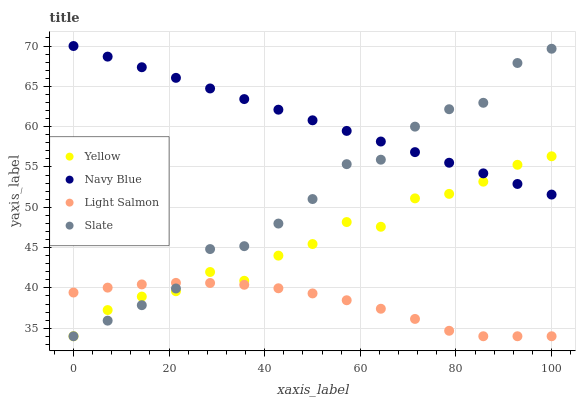Does Light Salmon have the minimum area under the curve?
Answer yes or no. Yes. Does Navy Blue have the maximum area under the curve?
Answer yes or no. Yes. Does Slate have the minimum area under the curve?
Answer yes or no. No. Does Slate have the maximum area under the curve?
Answer yes or no. No. Is Navy Blue the smoothest?
Answer yes or no. Yes. Is Slate the roughest?
Answer yes or no. Yes. Is Light Salmon the smoothest?
Answer yes or no. No. Is Light Salmon the roughest?
Answer yes or no. No. Does Light Salmon have the lowest value?
Answer yes or no. Yes. Does Navy Blue have the highest value?
Answer yes or no. Yes. Does Slate have the highest value?
Answer yes or no. No. Is Light Salmon less than Navy Blue?
Answer yes or no. Yes. Is Navy Blue greater than Light Salmon?
Answer yes or no. Yes. Does Yellow intersect Slate?
Answer yes or no. Yes. Is Yellow less than Slate?
Answer yes or no. No. Is Yellow greater than Slate?
Answer yes or no. No. Does Light Salmon intersect Navy Blue?
Answer yes or no. No. 